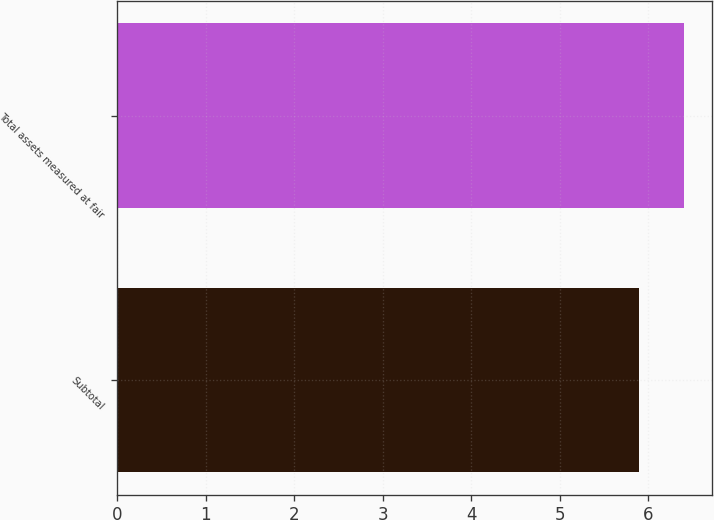Convert chart. <chart><loc_0><loc_0><loc_500><loc_500><bar_chart><fcel>Subtotal<fcel>Total assets measured at fair<nl><fcel>5.9<fcel>6.4<nl></chart> 